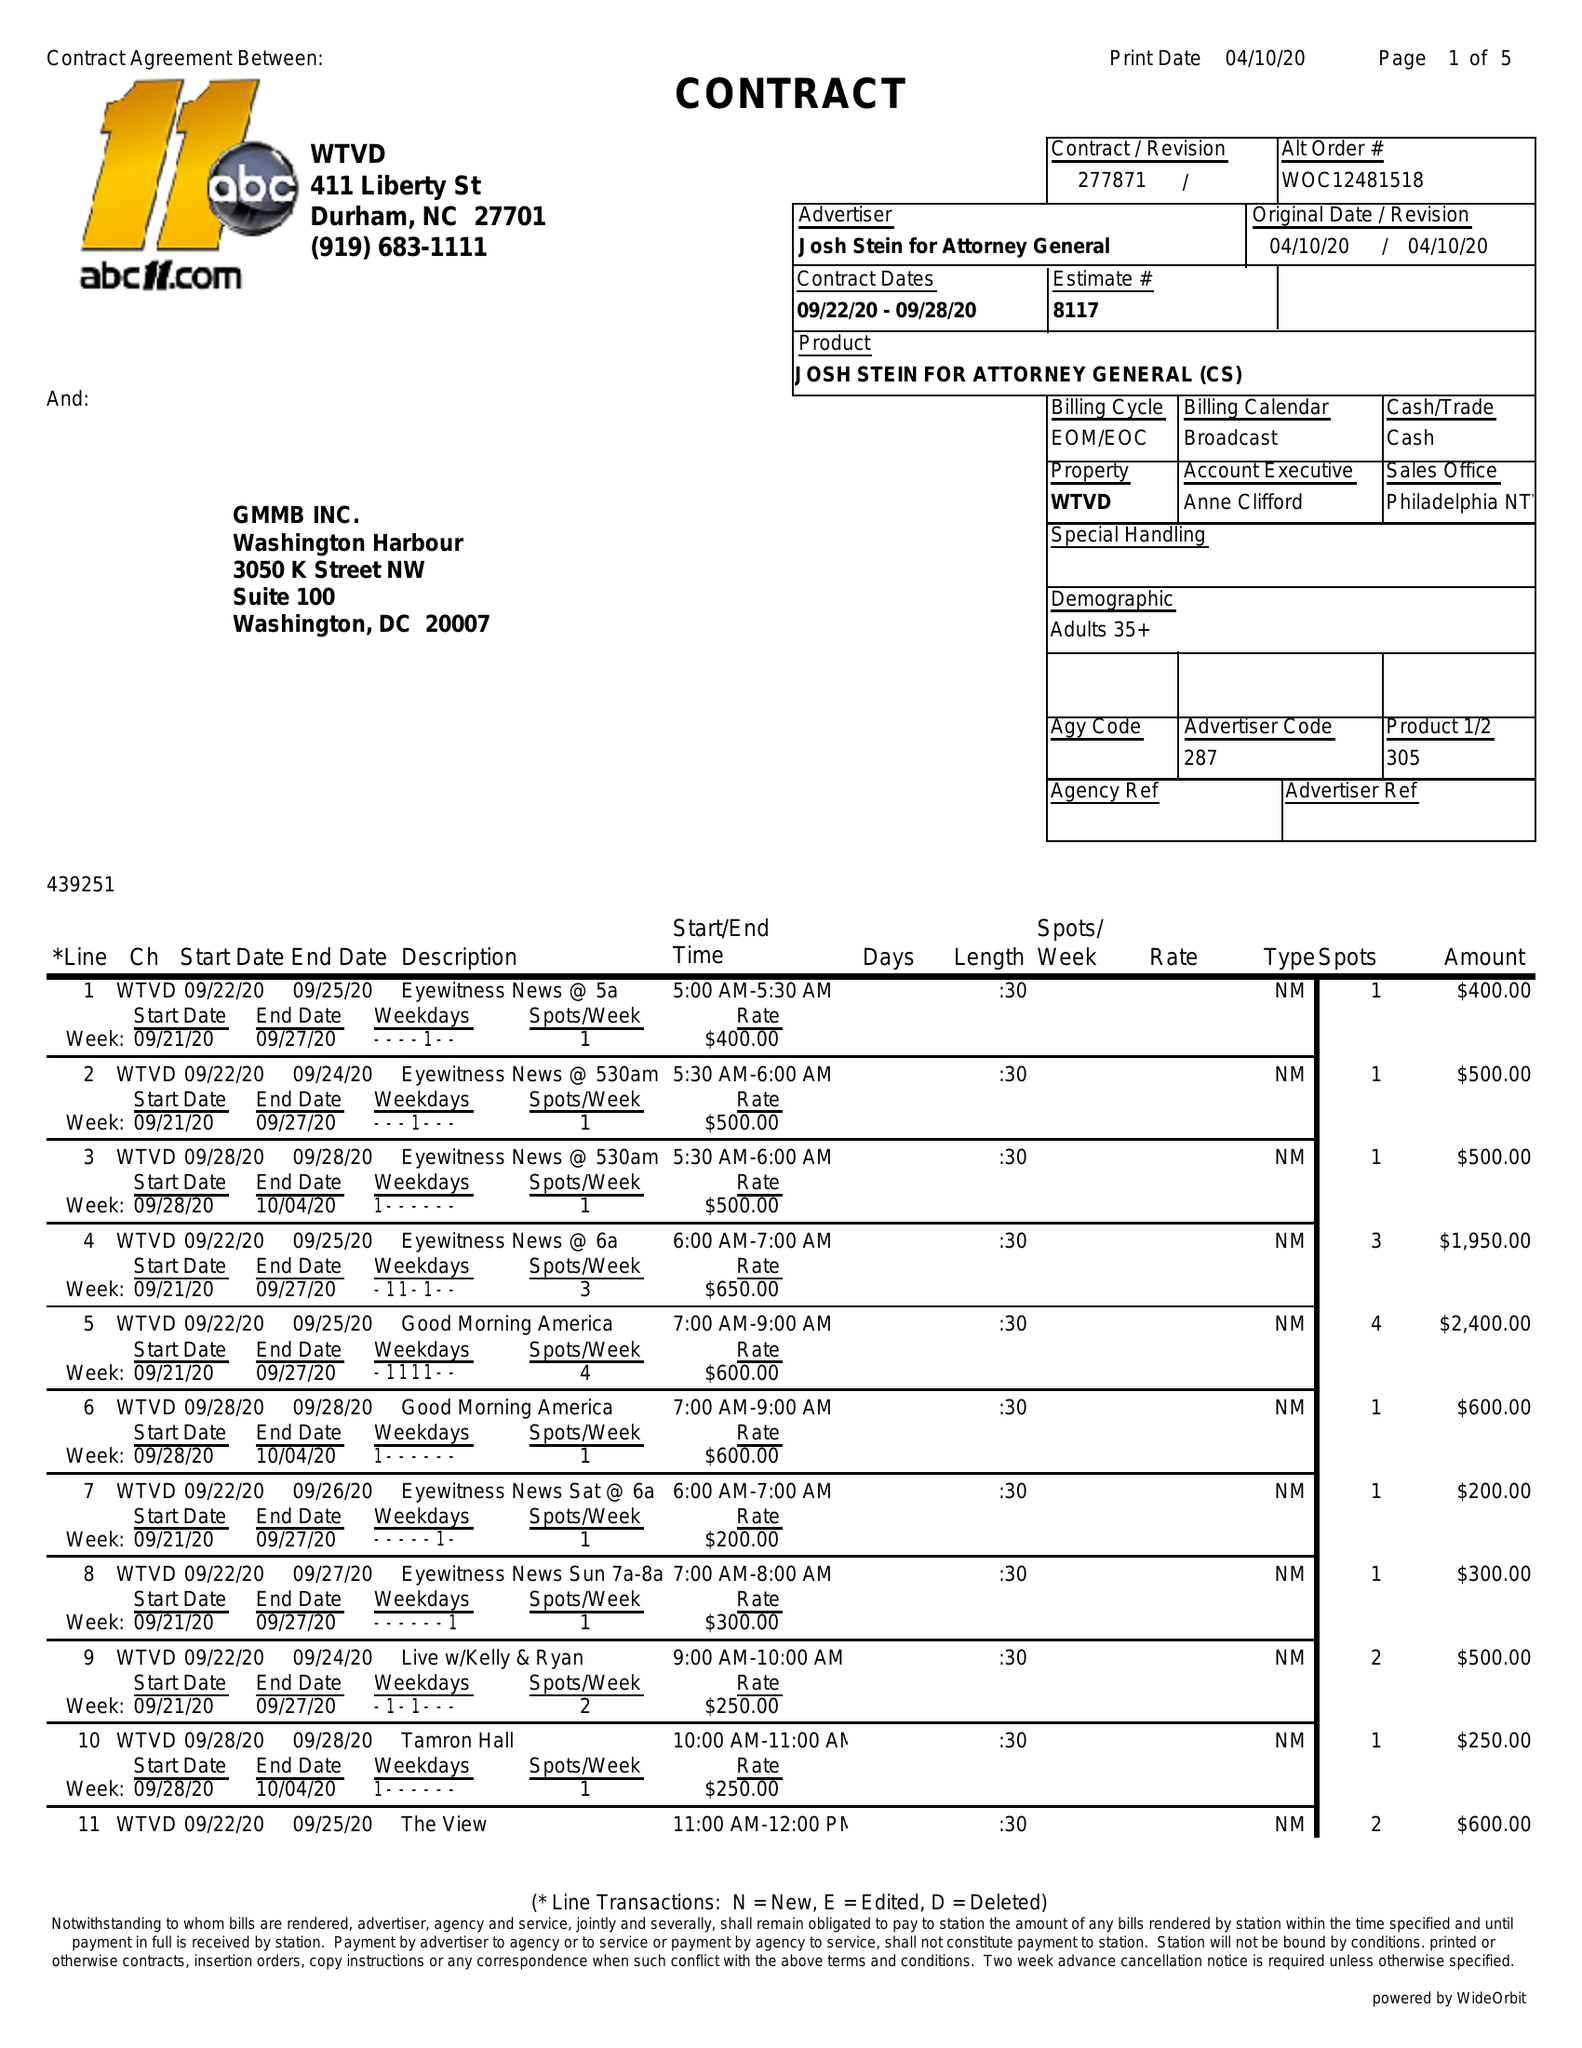What is the value for the contract_num?
Answer the question using a single word or phrase. 277871 